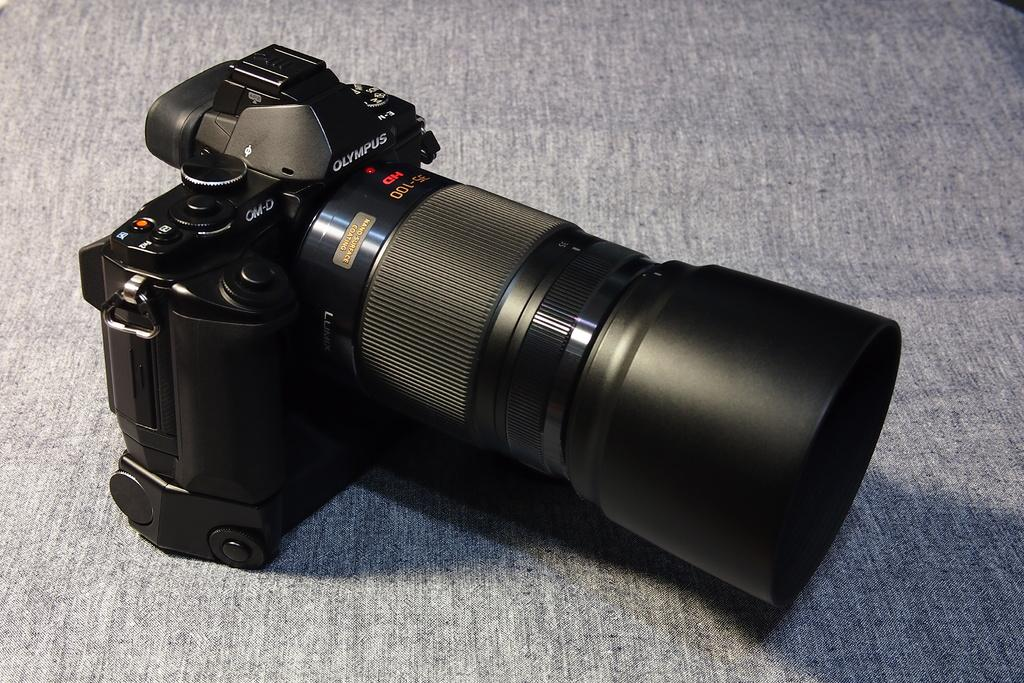What is the main object in the image? There is a camera in the image. Can you describe the background of the image? There is a surface visible in the background of the image. What type of juice is being served in the image? There is no juice present in the image; it only features a camera and a background surface. 